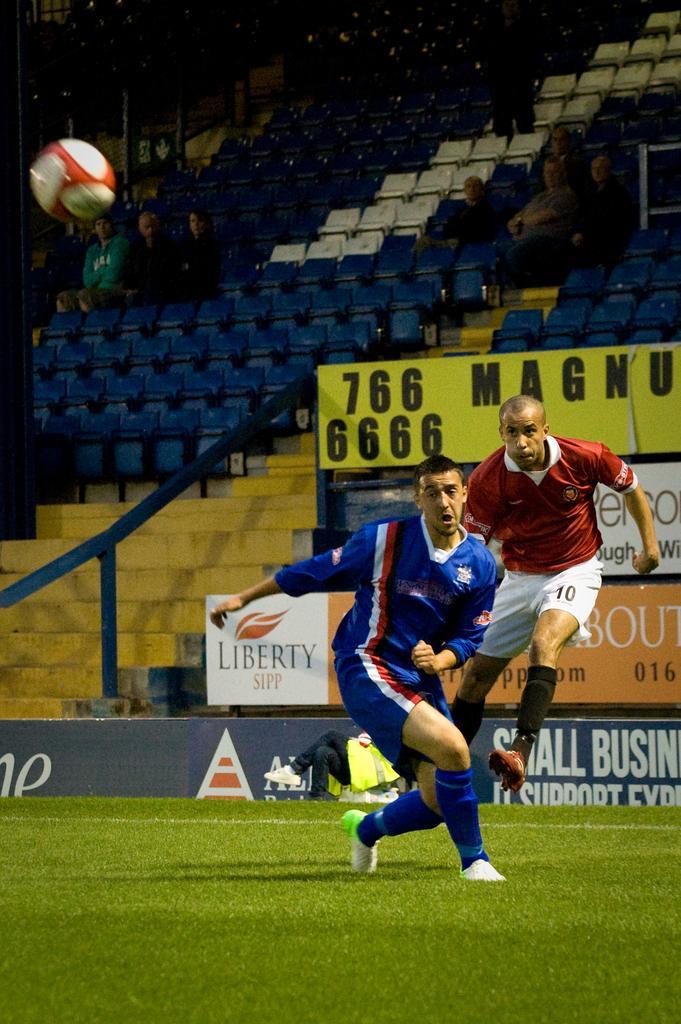How would you summarize this image in a sentence or two? In this image we can see two people running. At the bottom of the image there is grass. To the left side of the image there is football. In the background of the image there are stands. There are people sitting in stands. There are advertisement boards. 